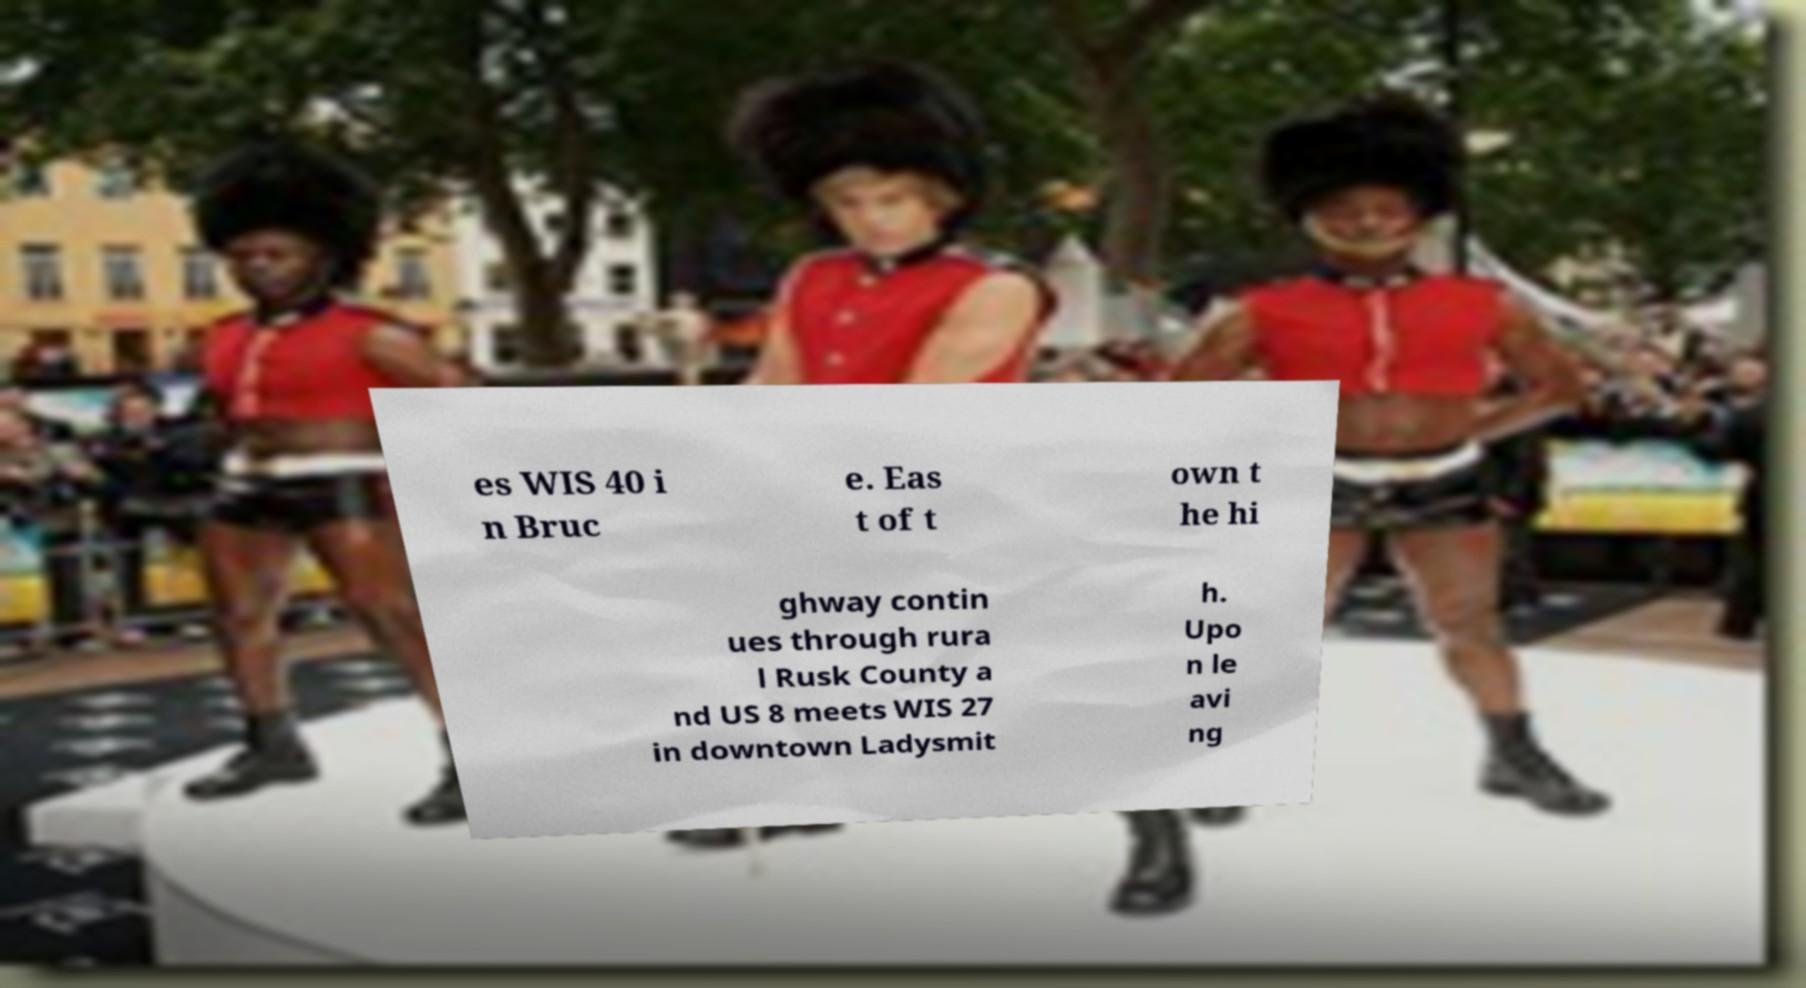Can you read and provide the text displayed in the image?This photo seems to have some interesting text. Can you extract and type it out for me? es WIS 40 i n Bruc e. Eas t of t own t he hi ghway contin ues through rura l Rusk County a nd US 8 meets WIS 27 in downtown Ladysmit h. Upo n le avi ng 